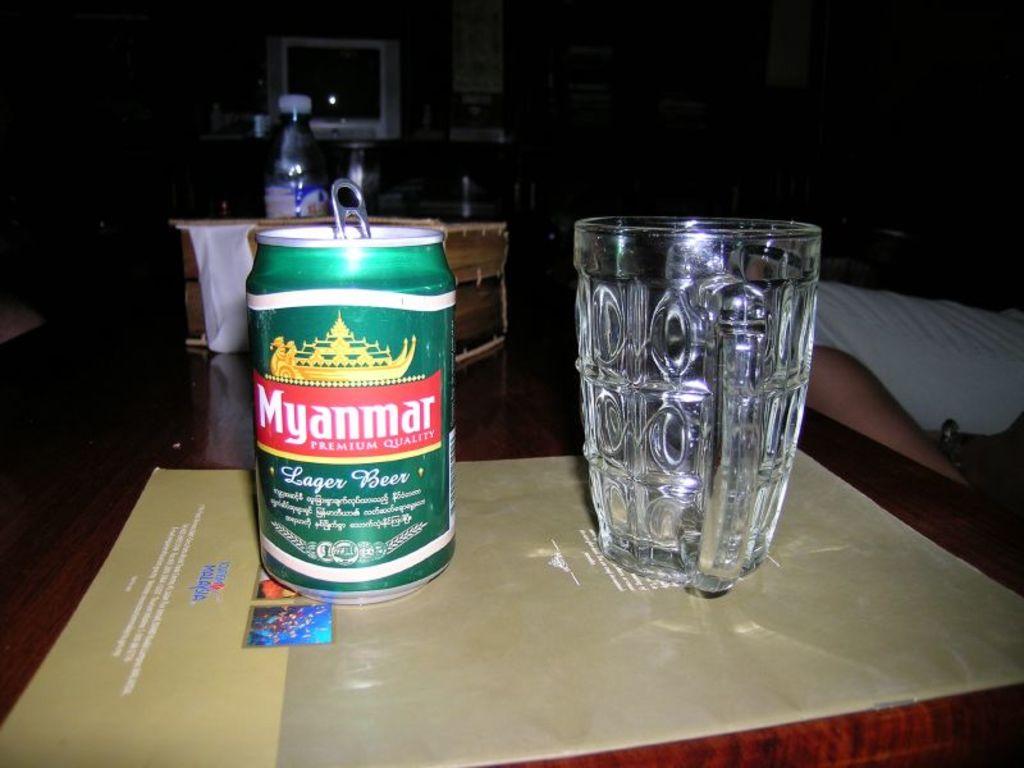Is this lager beer?
Provide a short and direct response. Yes. What brand is the beer?
Give a very brief answer. Myanmar. 